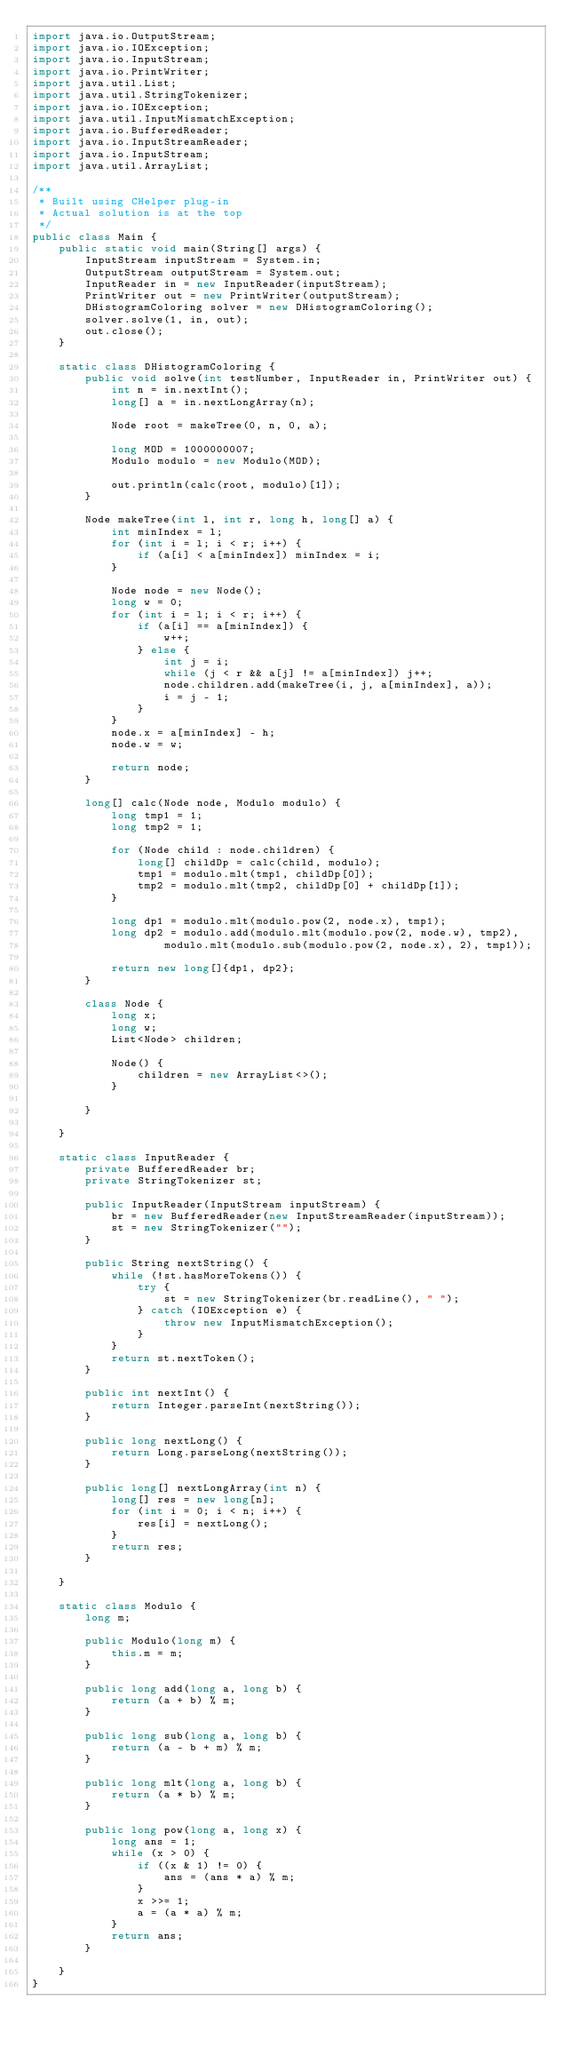Convert code to text. <code><loc_0><loc_0><loc_500><loc_500><_Java_>import java.io.OutputStream;
import java.io.IOException;
import java.io.InputStream;
import java.io.PrintWriter;
import java.util.List;
import java.util.StringTokenizer;
import java.io.IOException;
import java.util.InputMismatchException;
import java.io.BufferedReader;
import java.io.InputStreamReader;
import java.io.InputStream;
import java.util.ArrayList;

/**
 * Built using CHelper plug-in
 * Actual solution is at the top
 */
public class Main {
    public static void main(String[] args) {
        InputStream inputStream = System.in;
        OutputStream outputStream = System.out;
        InputReader in = new InputReader(inputStream);
        PrintWriter out = new PrintWriter(outputStream);
        DHistogramColoring solver = new DHistogramColoring();
        solver.solve(1, in, out);
        out.close();
    }

    static class DHistogramColoring {
        public void solve(int testNumber, InputReader in, PrintWriter out) {
            int n = in.nextInt();
            long[] a = in.nextLongArray(n);

            Node root = makeTree(0, n, 0, a);

            long MOD = 1000000007;
            Modulo modulo = new Modulo(MOD);

            out.println(calc(root, modulo)[1]);
        }

        Node makeTree(int l, int r, long h, long[] a) {
            int minIndex = l;
            for (int i = l; i < r; i++) {
                if (a[i] < a[minIndex]) minIndex = i;
            }

            Node node = new Node();
            long w = 0;
            for (int i = l; i < r; i++) {
                if (a[i] == a[minIndex]) {
                    w++;
                } else {
                    int j = i;
                    while (j < r && a[j] != a[minIndex]) j++;
                    node.children.add(makeTree(i, j, a[minIndex], a));
                    i = j - 1;
                }
            }
            node.x = a[minIndex] - h;
            node.w = w;

            return node;
        }

        long[] calc(Node node, Modulo modulo) {
            long tmp1 = 1;
            long tmp2 = 1;

            for (Node child : node.children) {
                long[] childDp = calc(child, modulo);
                tmp1 = modulo.mlt(tmp1, childDp[0]);
                tmp2 = modulo.mlt(tmp2, childDp[0] + childDp[1]);
            }

            long dp1 = modulo.mlt(modulo.pow(2, node.x), tmp1);
            long dp2 = modulo.add(modulo.mlt(modulo.pow(2, node.w), tmp2),
                    modulo.mlt(modulo.sub(modulo.pow(2, node.x), 2), tmp1));

            return new long[]{dp1, dp2};
        }

        class Node {
            long x;
            long w;
            List<Node> children;

            Node() {
                children = new ArrayList<>();
            }

        }

    }

    static class InputReader {
        private BufferedReader br;
        private StringTokenizer st;

        public InputReader(InputStream inputStream) {
            br = new BufferedReader(new InputStreamReader(inputStream));
            st = new StringTokenizer("");
        }

        public String nextString() {
            while (!st.hasMoreTokens()) {
                try {
                    st = new StringTokenizer(br.readLine(), " ");
                } catch (IOException e) {
                    throw new InputMismatchException();
                }
            }
            return st.nextToken();
        }

        public int nextInt() {
            return Integer.parseInt(nextString());
        }

        public long nextLong() {
            return Long.parseLong(nextString());
        }

        public long[] nextLongArray(int n) {
            long[] res = new long[n];
            for (int i = 0; i < n; i++) {
                res[i] = nextLong();
            }
            return res;
        }

    }

    static class Modulo {
        long m;

        public Modulo(long m) {
            this.m = m;
        }

        public long add(long a, long b) {
            return (a + b) % m;
        }

        public long sub(long a, long b) {
            return (a - b + m) % m;
        }

        public long mlt(long a, long b) {
            return (a * b) % m;
        }

        public long pow(long a, long x) {
            long ans = 1;
            while (x > 0) {
                if ((x & 1) != 0) {
                    ans = (ans * a) % m;
                }
                x >>= 1;
                a = (a * a) % m;
            }
            return ans;
        }

    }
}

</code> 